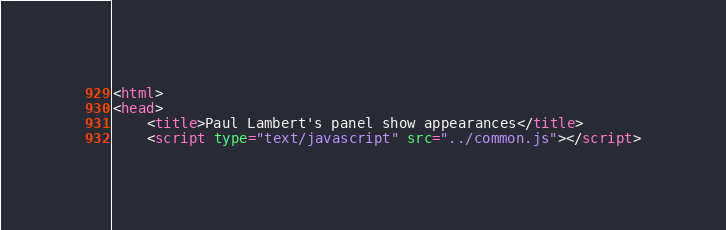Convert code to text. <code><loc_0><loc_0><loc_500><loc_500><_HTML_><html>
<head>
	<title>Paul Lambert's panel show appearances</title>
	<script type="text/javascript" src="../common.js"></script></code> 